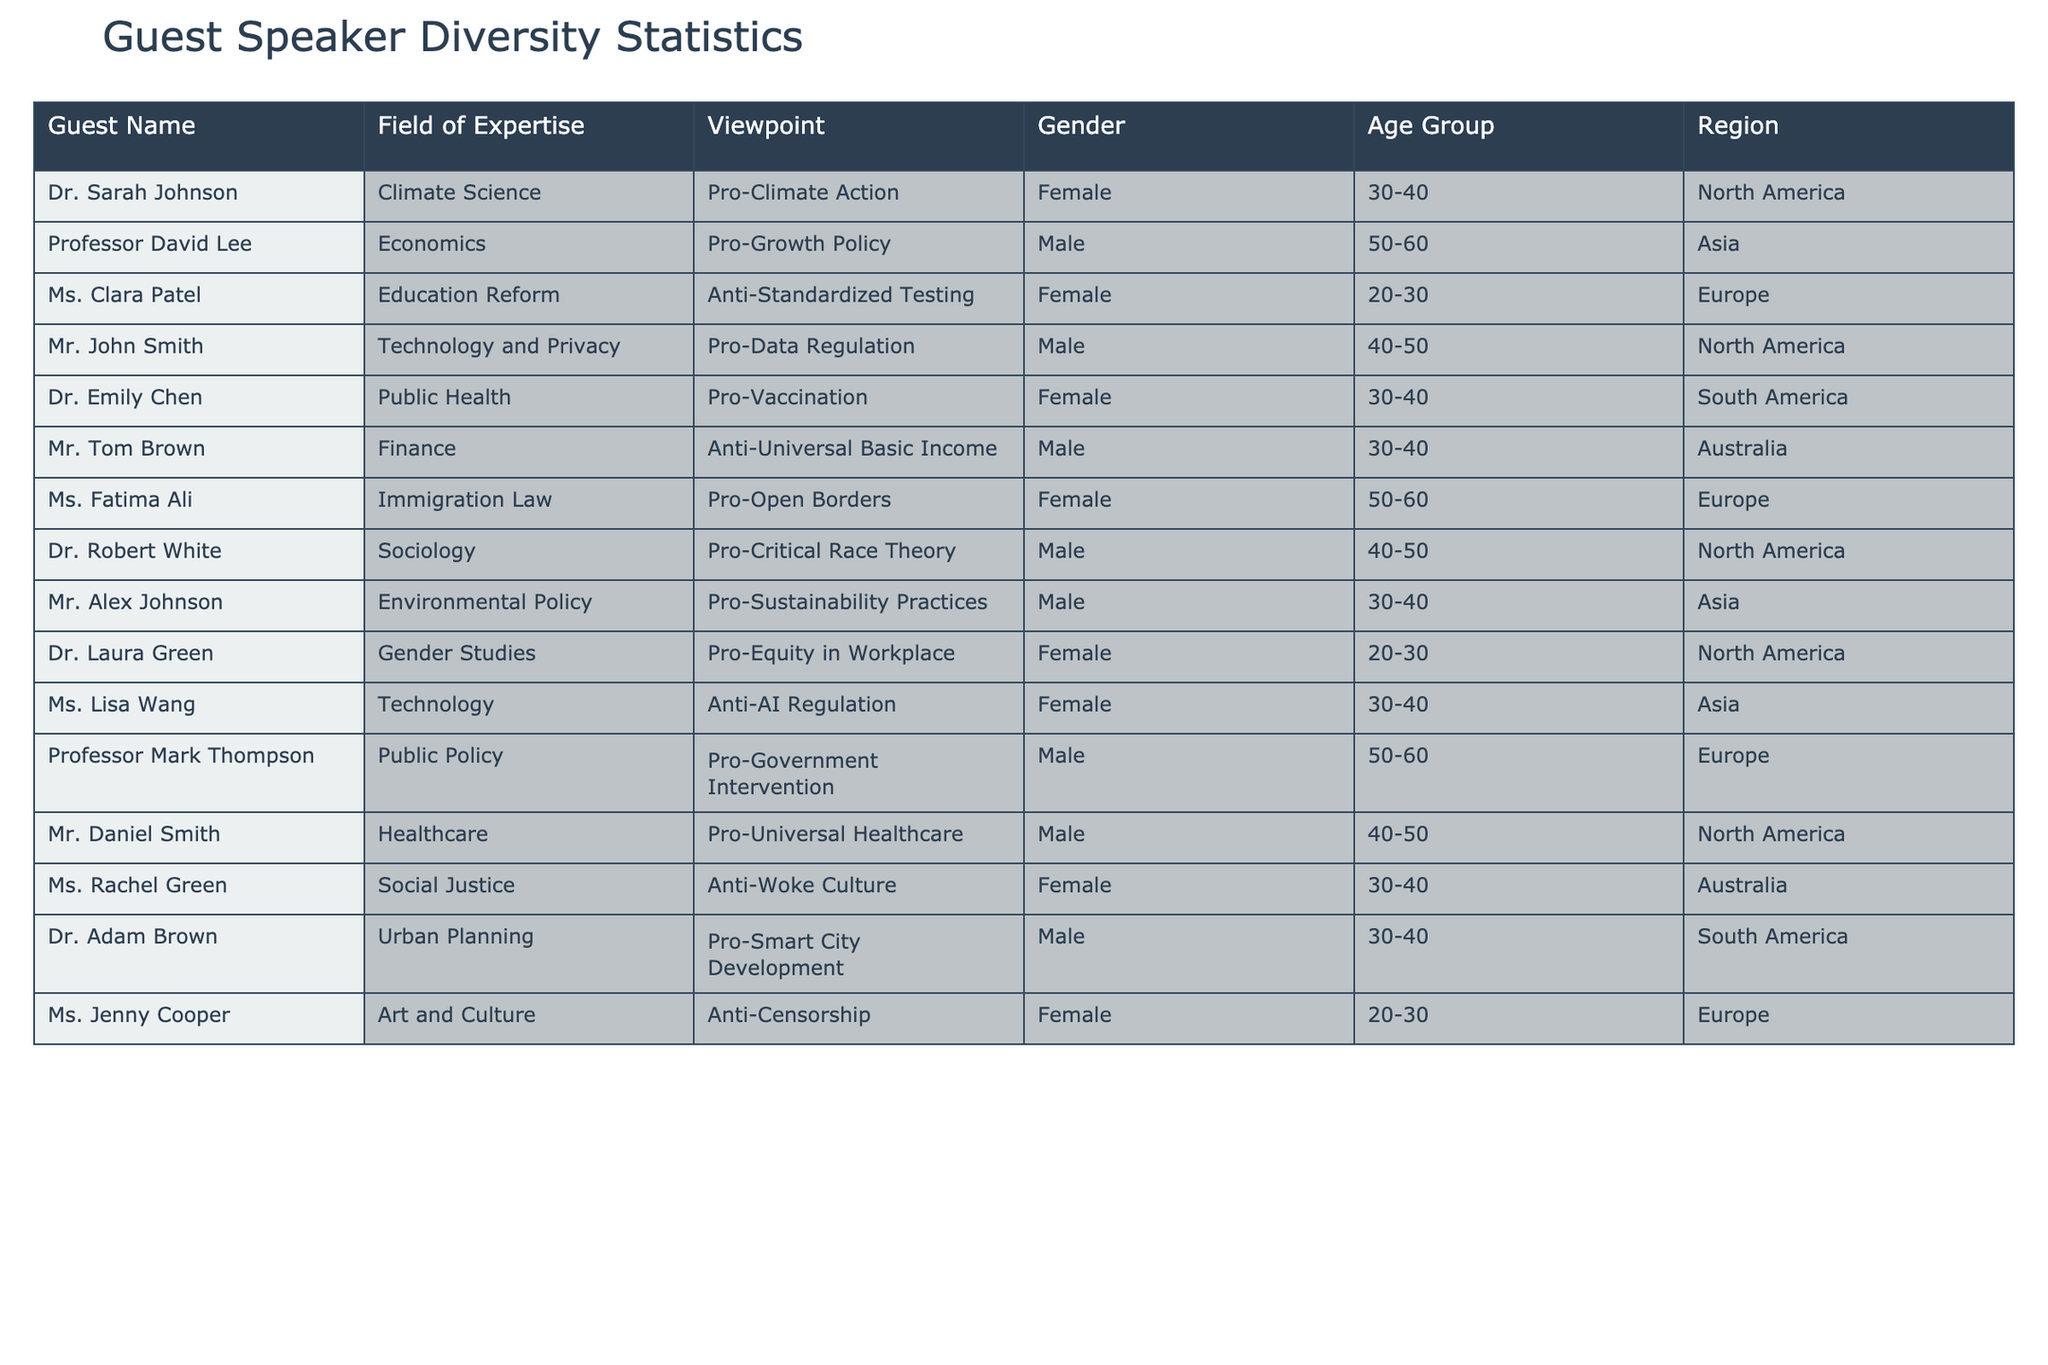What is the total number of guest speakers from North America? In the table, we look for the 'Region' column and count how many speakers are listed as 'North America'. There are four guest speakers: Dr. Sarah Johnson, Mr. John Smith, Dr. Robert White, and Mr. Daniel Smith. Thus, the total is 4.
Answer: 4 Which gender has more representation among the guest speakers? We can tally the number of males and females in the 'Gender' column. There are 6 males (Professor David Lee, Mr. John Smith, Mr. Tom Brown, Dr. Robert White, Mr. Daniel Smith, Mr. Adam Brown) and 6 females (Dr. Sarah Johnson, Ms. Clara Patel, Dr. Emily Chen, Ms. Fatima Ali, Dr. Laura Green, Ms. Rachel Green, Ms. Jenny Cooper). The numbers are equal; therefore, neither gender has more representation.
Answer: Equal representation How many guest speakers are against Universal Basic Income? We can filter through the 'Viewpoint' column and identify those specifically mentioned as 'Anti-Universal Basic Income'. There is 1 guest speaker, Mr. Tom Brown.
Answer: 1 Are there more anti-standards testing guests compared to pro-growth policy guests? We review the 'Viewpoint' column. The term 'Anti-Standardized Testing' corresponds to Ms. Clara Patel while 'Pro-Growth Policy' corresponds to Professor David Lee. Counting both, there is 1 guest speaker against standardized testing and 1 in favor of growth policy. Thus, they are equal.
Answer: Equal numbers What percentage of the guest speakers comes from Europe? First, we count the total number of guest speakers which is 12. Next, we count how many guest speakers are from Europe: Ms. Clara Patel, Ms. Fatima Ali, Professor Mark Thompson, and Ms. Jenny Cooper, totaling 4. To find the percentage, we use the formula (4/12) * 100 = 33.33%.
Answer: 33.33% How many guest speakers have a viewpoint in favor of sustainability practices? We look for guest speakers in the 'Viewpoint' column that mention 'Pro-Sustainability Practices', which we find relates to Mr. Alex Johnson. Therefore, there is only 1 guest speaker in favor of these practices.
Answer: 1 Which viewpoint has the highest number of guest speakers? We need to analyze the guest speakers' viewpoints and tally those. The viewpoints mentioned include 'Pro-Climate Action', 'Pro-Growth Policy', 'Anti-Standardized Testing', 'Pro-Data Regulation', 'Pro-Vaccination', 'Anti-Universal Basic Income', and several more. After counting, 'Pro' viewpoints total up to 8 guest speakers overall, while 'Anti' viewpoints add up to 3, indicating pro viewpoints have the highest number of representatives.
Answer: Pro viewpoints Is there any guest speaker above the age of 60? We check the 'Age Group' column for any entries older than 60. All listed guests fall within age groups 20-30, 30-40, 40-50, and 50-60. Therefore, none of the guest speakers are above the age of 60.
Answer: No 